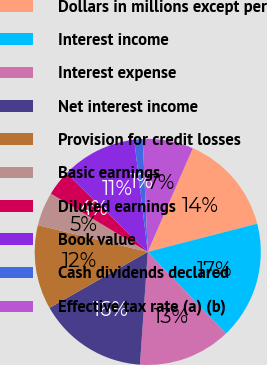<chart> <loc_0><loc_0><loc_500><loc_500><pie_chart><fcel>Dollars in millions except per<fcel>Interest income<fcel>Interest expense<fcel>Net interest income<fcel>Provision for credit losses<fcel>Basic earnings<fcel>Diluted earnings<fcel>Book value<fcel>Cash dividends declared<fcel>Effective tax rate (a) (b)<nl><fcel>14.46%<fcel>16.87%<fcel>13.25%<fcel>15.66%<fcel>12.05%<fcel>4.82%<fcel>3.62%<fcel>10.84%<fcel>1.21%<fcel>7.23%<nl></chart> 